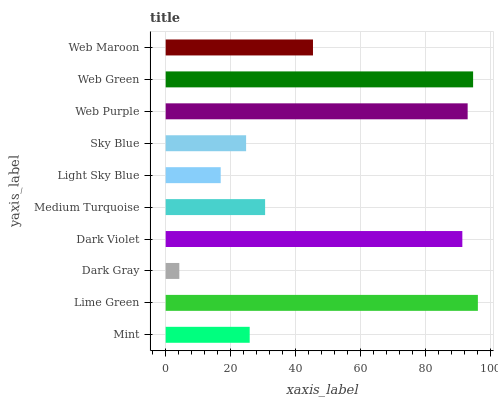Is Dark Gray the minimum?
Answer yes or no. Yes. Is Lime Green the maximum?
Answer yes or no. Yes. Is Lime Green the minimum?
Answer yes or no. No. Is Dark Gray the maximum?
Answer yes or no. No. Is Lime Green greater than Dark Gray?
Answer yes or no. Yes. Is Dark Gray less than Lime Green?
Answer yes or no. Yes. Is Dark Gray greater than Lime Green?
Answer yes or no. No. Is Lime Green less than Dark Gray?
Answer yes or no. No. Is Web Maroon the high median?
Answer yes or no. Yes. Is Medium Turquoise the low median?
Answer yes or no. Yes. Is Light Sky Blue the high median?
Answer yes or no. No. Is Sky Blue the low median?
Answer yes or no. No. 